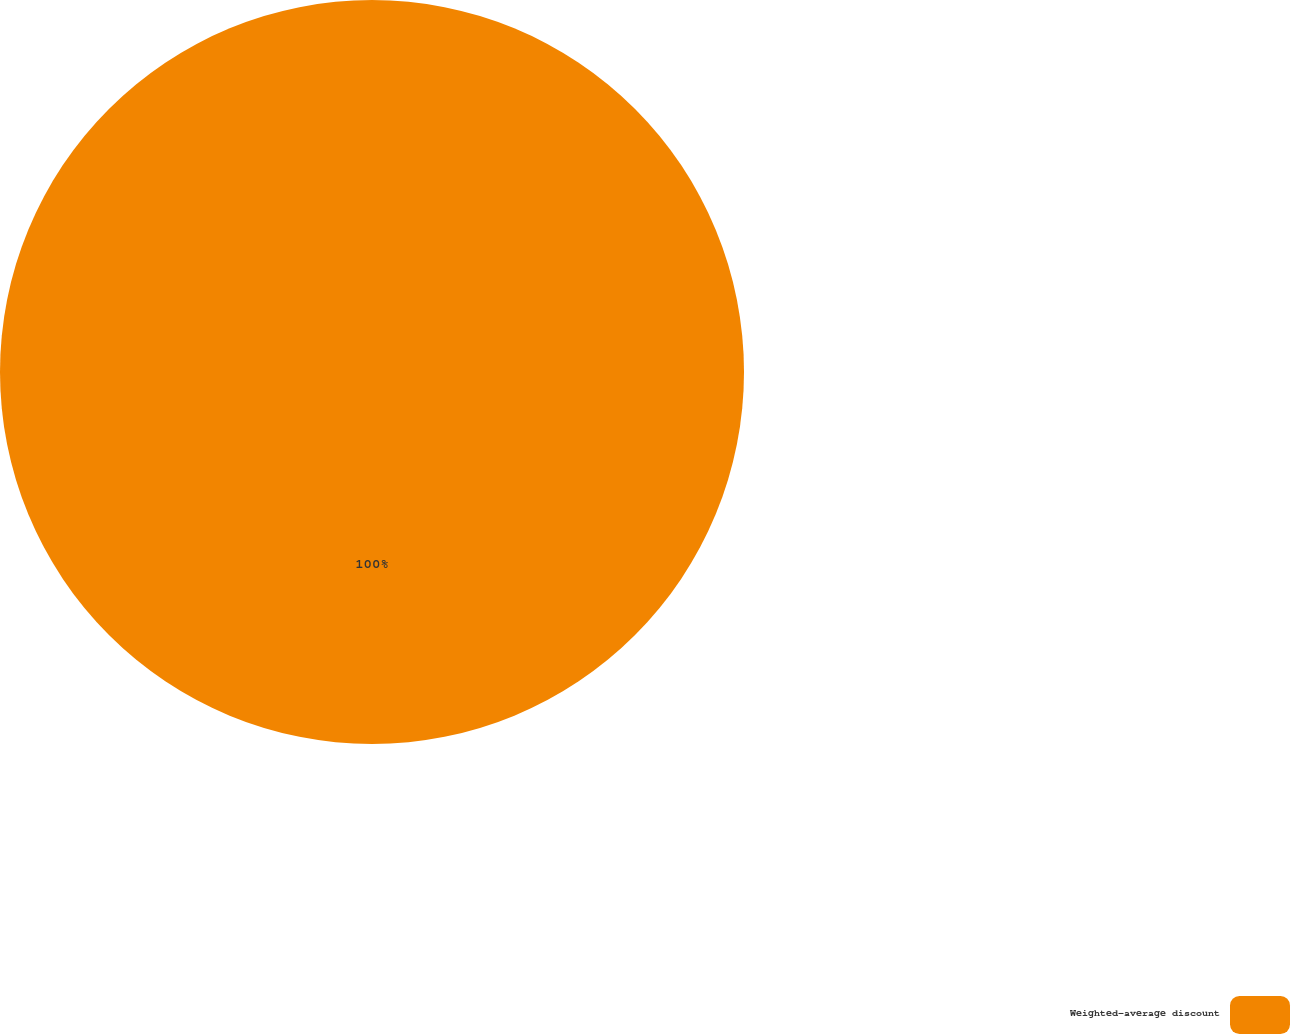Convert chart to OTSL. <chart><loc_0><loc_0><loc_500><loc_500><pie_chart><fcel>Weighted-average discount<nl><fcel>100.0%<nl></chart> 